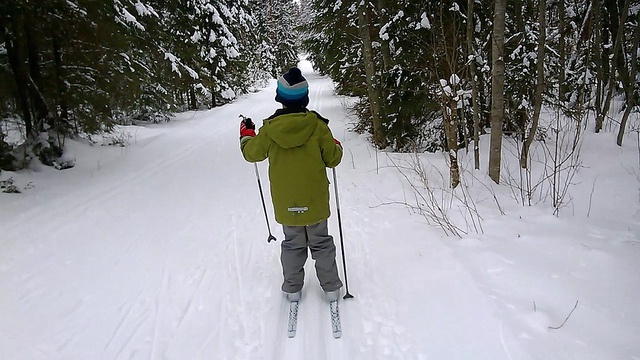Describe the objects in this image and their specific colors. I can see people in black, darkgreen, gray, and darkgray tones and skis in black, darkgray, lightgray, and gray tones in this image. 